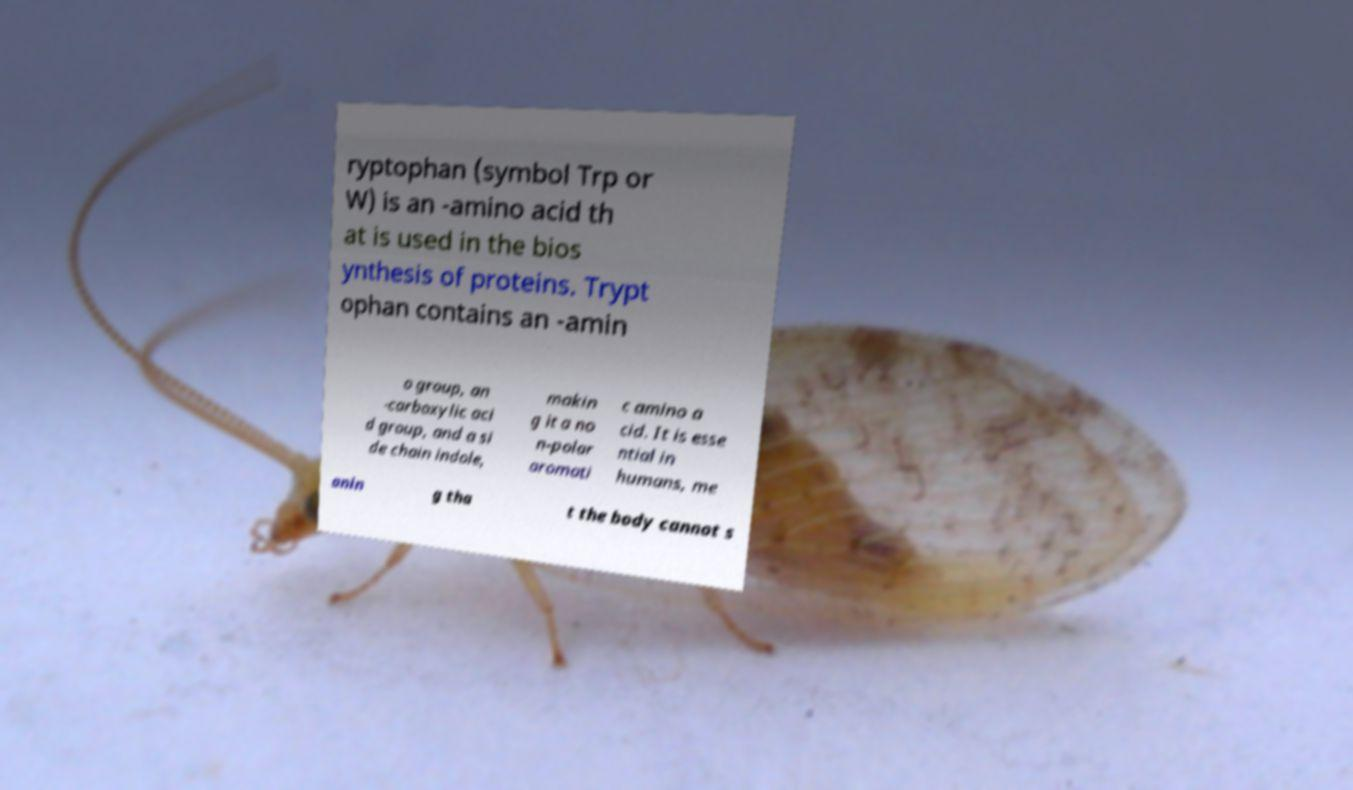I need the written content from this picture converted into text. Can you do that? ryptophan (symbol Trp or W) is an -amino acid th at is used in the bios ynthesis of proteins. Trypt ophan contains an -amin o group, an -carboxylic aci d group, and a si de chain indole, makin g it a no n-polar aromati c amino a cid. It is esse ntial in humans, me anin g tha t the body cannot s 